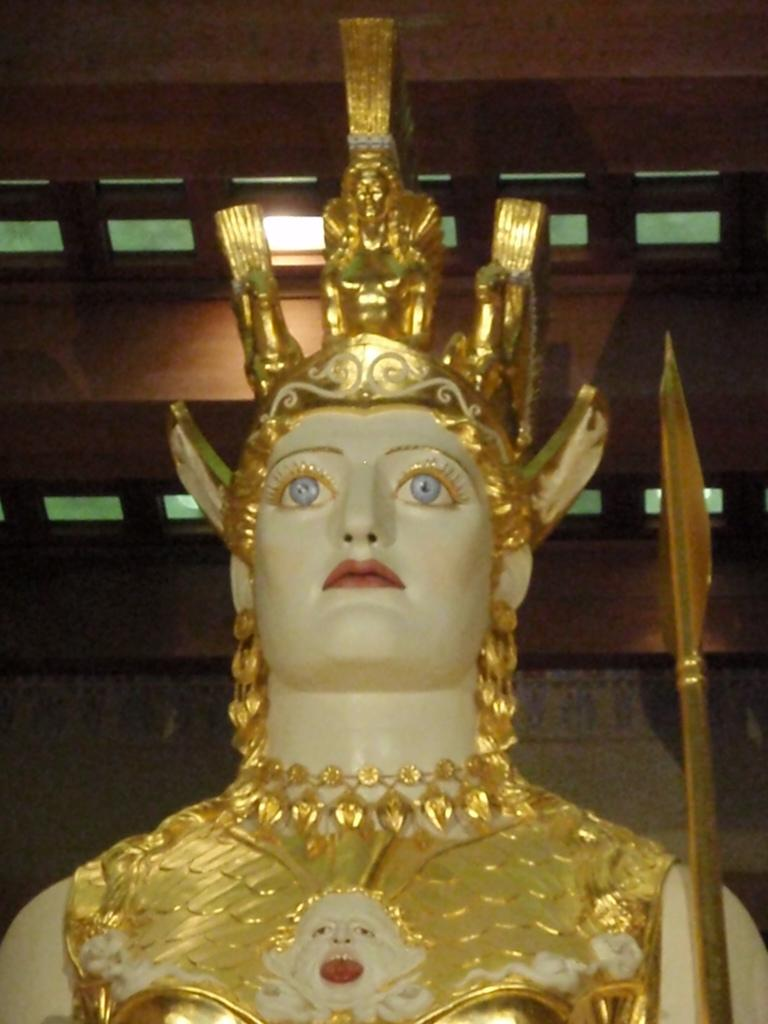What is the main subject of the image? There is a statue or the Parthenon in the image. What is the statue or the Parthenon a representation of? The statue or the Parthenon is of a woman. What can be seen in the background of the image? There is a brown wall in the background of the image. Can you see any planes flying in the image? No, there are no planes visible in the image. Is there a basin filled with popcorn in the image? No, there is no basin or popcorn present in the image. 